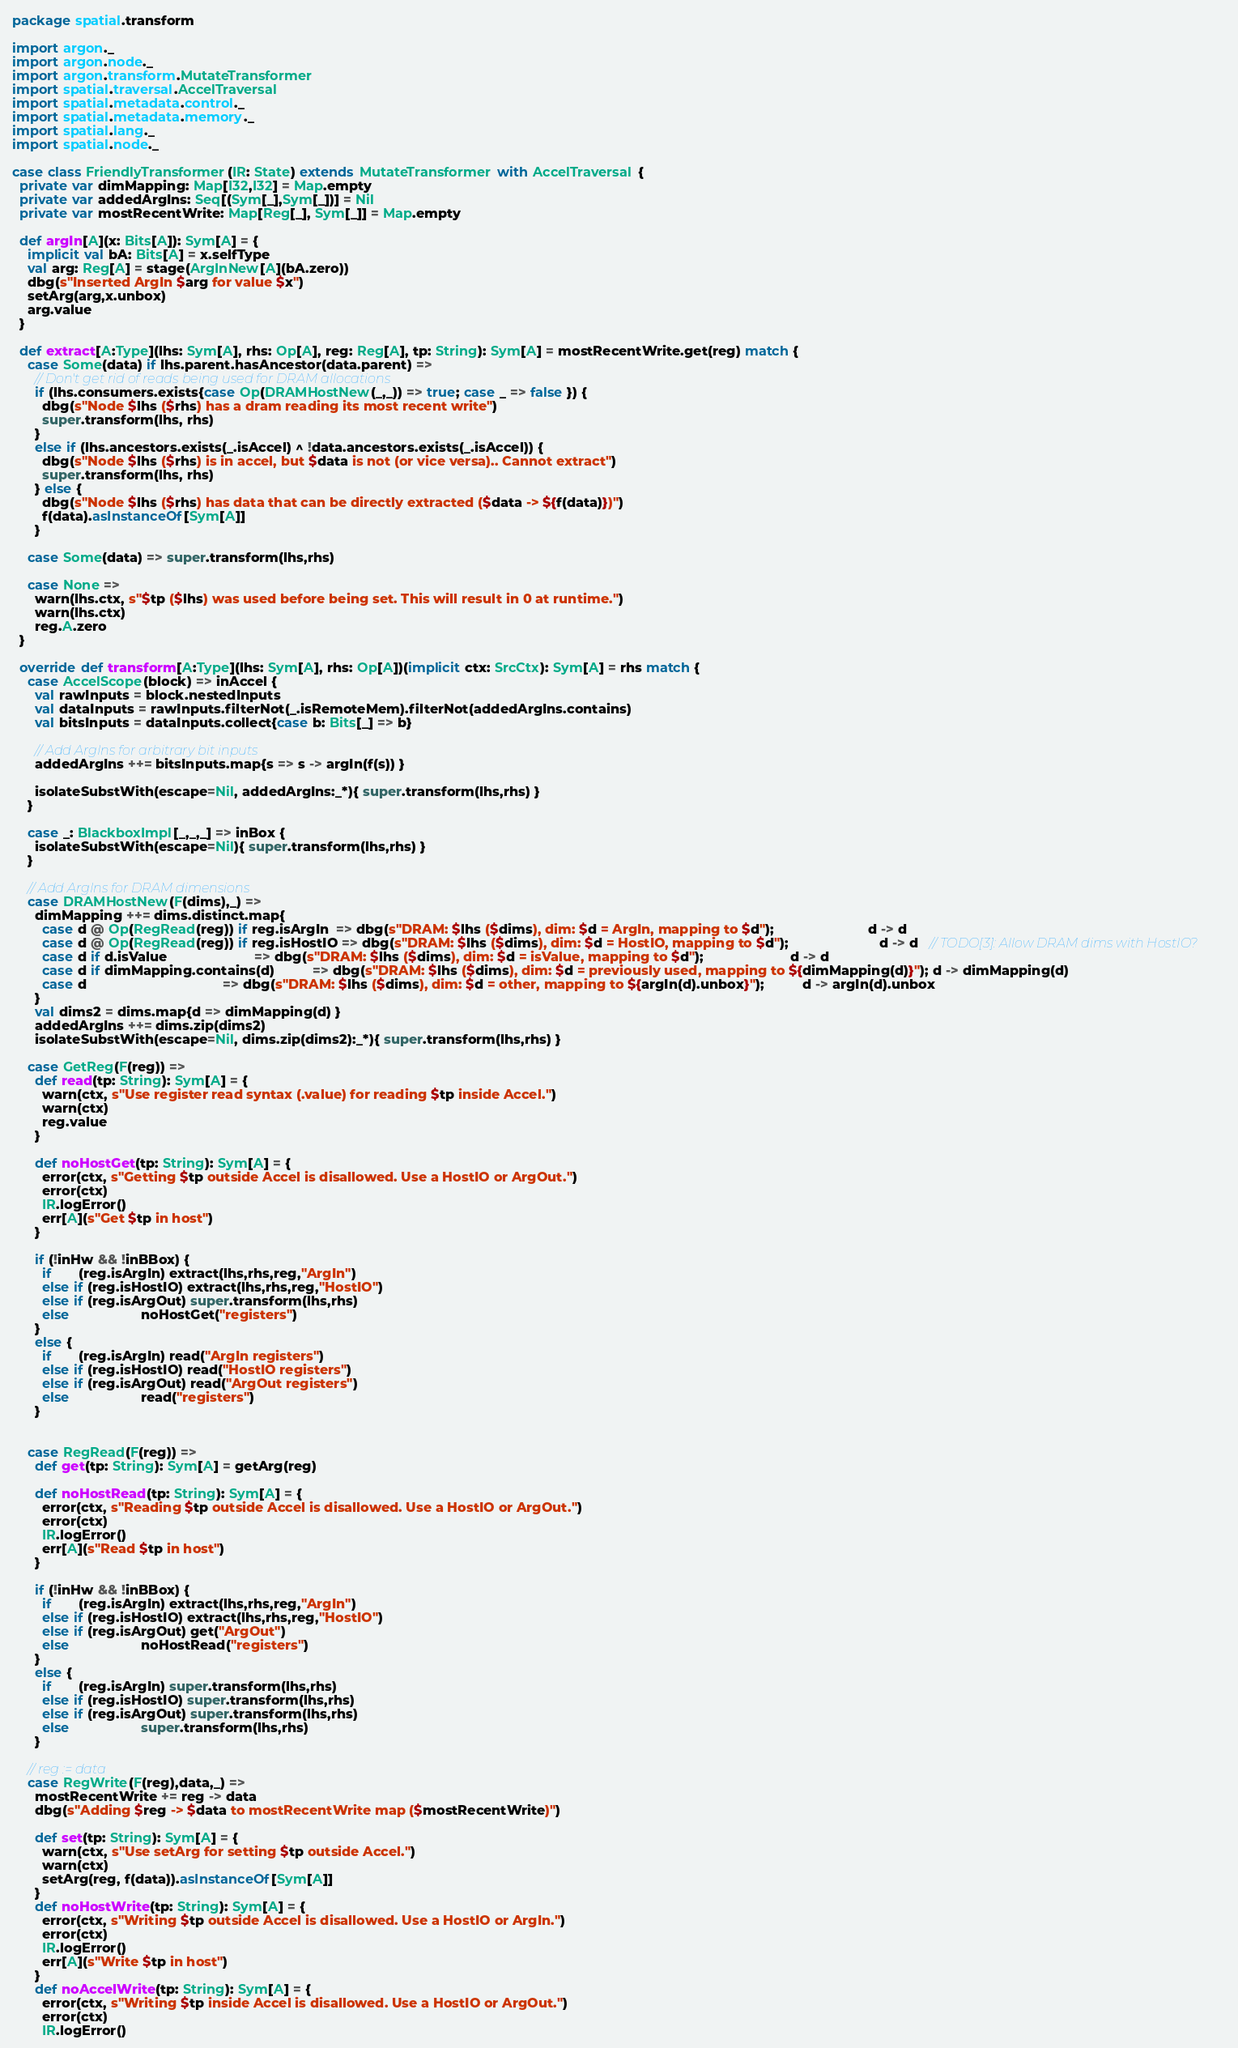Convert code to text. <code><loc_0><loc_0><loc_500><loc_500><_Scala_>package spatial.transform

import argon._
import argon.node._
import argon.transform.MutateTransformer
import spatial.traversal.AccelTraversal
import spatial.metadata.control._
import spatial.metadata.memory._
import spatial.lang._
import spatial.node._

case class FriendlyTransformer(IR: State) extends MutateTransformer with AccelTraversal {
  private var dimMapping: Map[I32,I32] = Map.empty
  private var addedArgIns: Seq[(Sym[_],Sym[_])] = Nil
  private var mostRecentWrite: Map[Reg[_], Sym[_]] = Map.empty

  def argIn[A](x: Bits[A]): Sym[A] = {
    implicit val bA: Bits[A] = x.selfType
    val arg: Reg[A] = stage(ArgInNew[A](bA.zero))
    dbg(s"Inserted ArgIn $arg for value $x")
    setArg(arg,x.unbox)
    arg.value
  }

  def extract[A:Type](lhs: Sym[A], rhs: Op[A], reg: Reg[A], tp: String): Sym[A] = mostRecentWrite.get(reg) match {
    case Some(data) if lhs.parent.hasAncestor(data.parent) =>
      // Don't get rid of reads being used for DRAM allocations
      if (lhs.consumers.exists{case Op(DRAMHostNew(_,_)) => true; case _ => false }) {
        dbg(s"Node $lhs ($rhs) has a dram reading its most recent write")
        super.transform(lhs, rhs)
      }
      else if (lhs.ancestors.exists(_.isAccel) ^ !data.ancestors.exists(_.isAccel)) {
        dbg(s"Node $lhs ($rhs) is in accel, but $data is not (or vice versa).. Cannot extract")
        super.transform(lhs, rhs)
      } else {
        dbg(s"Node $lhs ($rhs) has data that can be directly extracted ($data -> ${f(data)})")
        f(data).asInstanceOf[Sym[A]]
      }

    case Some(data) => super.transform(lhs,rhs)

    case None =>
      warn(lhs.ctx, s"$tp ($lhs) was used before being set. This will result in 0 at runtime.")
      warn(lhs.ctx)
      reg.A.zero
  }

  override def transform[A:Type](lhs: Sym[A], rhs: Op[A])(implicit ctx: SrcCtx): Sym[A] = rhs match {
    case AccelScope(block) => inAccel {
      val rawInputs = block.nestedInputs
      val dataInputs = rawInputs.filterNot(_.isRemoteMem).filterNot(addedArgIns.contains)
      val bitsInputs = dataInputs.collect{case b: Bits[_] => b}

      // Add ArgIns for arbitrary bit inputs
      addedArgIns ++= bitsInputs.map{s => s -> argIn(f(s)) }

      isolateSubstWith(escape=Nil, addedArgIns:_*){ super.transform(lhs,rhs) }
    }

    case _: BlackboxImpl[_,_,_] => inBox {
      isolateSubstWith(escape=Nil){ super.transform(lhs,rhs) }
    }

    // Add ArgIns for DRAM dimensions
    case DRAMHostNew(F(dims),_) =>
      dimMapping ++= dims.distinct.map{
        case d @ Op(RegRead(reg)) if reg.isArgIn  => dbg(s"DRAM: $lhs ($dims), dim: $d = ArgIn, mapping to $d");                         d -> d
        case d @ Op(RegRead(reg)) if reg.isHostIO => dbg(s"DRAM: $lhs ($dims), dim: $d = HostIO, mapping to $d");                        d -> d   // TODO[3]: Allow DRAM dims with HostIO?
        case d if d.isValue                       => dbg(s"DRAM: $lhs ($dims), dim: $d = isValue, mapping to $d");                       d -> d
        case d if dimMapping.contains(d)          => dbg(s"DRAM: $lhs ($dims), dim: $d = previously used, mapping to ${dimMapping(d)}"); d -> dimMapping(d)
        case d                                    => dbg(s"DRAM: $lhs ($dims), dim: $d = other, mapping to ${argIn(d).unbox}");          d -> argIn(d).unbox
      }
      val dims2 = dims.map{d => dimMapping(d) }
      addedArgIns ++= dims.zip(dims2)
      isolateSubstWith(escape=Nil, dims.zip(dims2):_*){ super.transform(lhs,rhs) }

    case GetReg(F(reg)) =>
      def read(tp: String): Sym[A] = {
        warn(ctx, s"Use register read syntax (.value) for reading $tp inside Accel.")
        warn(ctx)
        reg.value
      }

      def noHostGet(tp: String): Sym[A] = {
        error(ctx, s"Getting $tp outside Accel is disallowed. Use a HostIO or ArgOut.")
        error(ctx)
        IR.logError()
        err[A](s"Get $tp in host")
      }

      if (!inHw && !inBBox) {
        if       (reg.isArgIn) extract(lhs,rhs,reg,"ArgIn")
        else if (reg.isHostIO) extract(lhs,rhs,reg,"HostIO")
        else if (reg.isArgOut) super.transform(lhs,rhs)
        else                   noHostGet("registers")
      }
      else {
        if       (reg.isArgIn) read("ArgIn registers")
        else if (reg.isHostIO) read("HostIO registers")
        else if (reg.isArgOut) read("ArgOut registers")
        else                   read("registers")
      }


    case RegRead(F(reg)) =>
      def get(tp: String): Sym[A] = getArg(reg)

      def noHostRead(tp: String): Sym[A] = {
        error(ctx, s"Reading $tp outside Accel is disallowed. Use a HostIO or ArgOut.")
        error(ctx)
        IR.logError()
        err[A](s"Read $tp in host")
      }

      if (!inHw && !inBBox) {
        if       (reg.isArgIn) extract(lhs,rhs,reg,"ArgIn")
        else if (reg.isHostIO) extract(lhs,rhs,reg,"HostIO")
        else if (reg.isArgOut) get("ArgOut")
        else                   noHostRead("registers")
      }
      else {
        if       (reg.isArgIn) super.transform(lhs,rhs)
        else if (reg.isHostIO) super.transform(lhs,rhs)
        else if (reg.isArgOut) super.transform(lhs,rhs)
        else                   super.transform(lhs,rhs)
      }

    // reg := data
    case RegWrite(F(reg),data,_) =>
      mostRecentWrite += reg -> data
      dbg(s"Adding $reg -> $data to mostRecentWrite map ($mostRecentWrite)")

      def set(tp: String): Sym[A] = {
        warn(ctx, s"Use setArg for setting $tp outside Accel.")
        warn(ctx)
        setArg(reg, f(data)).asInstanceOf[Sym[A]]
      }
      def noHostWrite(tp: String): Sym[A] = {
        error(ctx, s"Writing $tp outside Accel is disallowed. Use a HostIO or ArgIn.")
        error(ctx)
        IR.logError()
        err[A](s"Write $tp in host")
      }
      def noAccelWrite(tp: String): Sym[A] = {
        error(ctx, s"Writing $tp inside Accel is disallowed. Use a HostIO or ArgOut.")
        error(ctx)
        IR.logError()</code> 